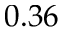<formula> <loc_0><loc_0><loc_500><loc_500>0 . 3 6</formula> 